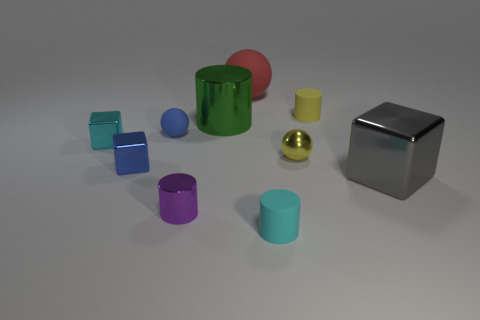Subtract all small shiny cubes. How many cubes are left? 1 Subtract 1 spheres. How many spheres are left? 2 Subtract all gray cylinders. Subtract all brown balls. How many cylinders are left? 4 Subtract all spheres. Subtract all blue metallic things. How many objects are left? 6 Add 5 blue matte balls. How many blue matte balls are left? 6 Add 8 small balls. How many small balls exist? 10 Subtract 0 green spheres. How many objects are left? 10 Subtract all cylinders. How many objects are left? 6 